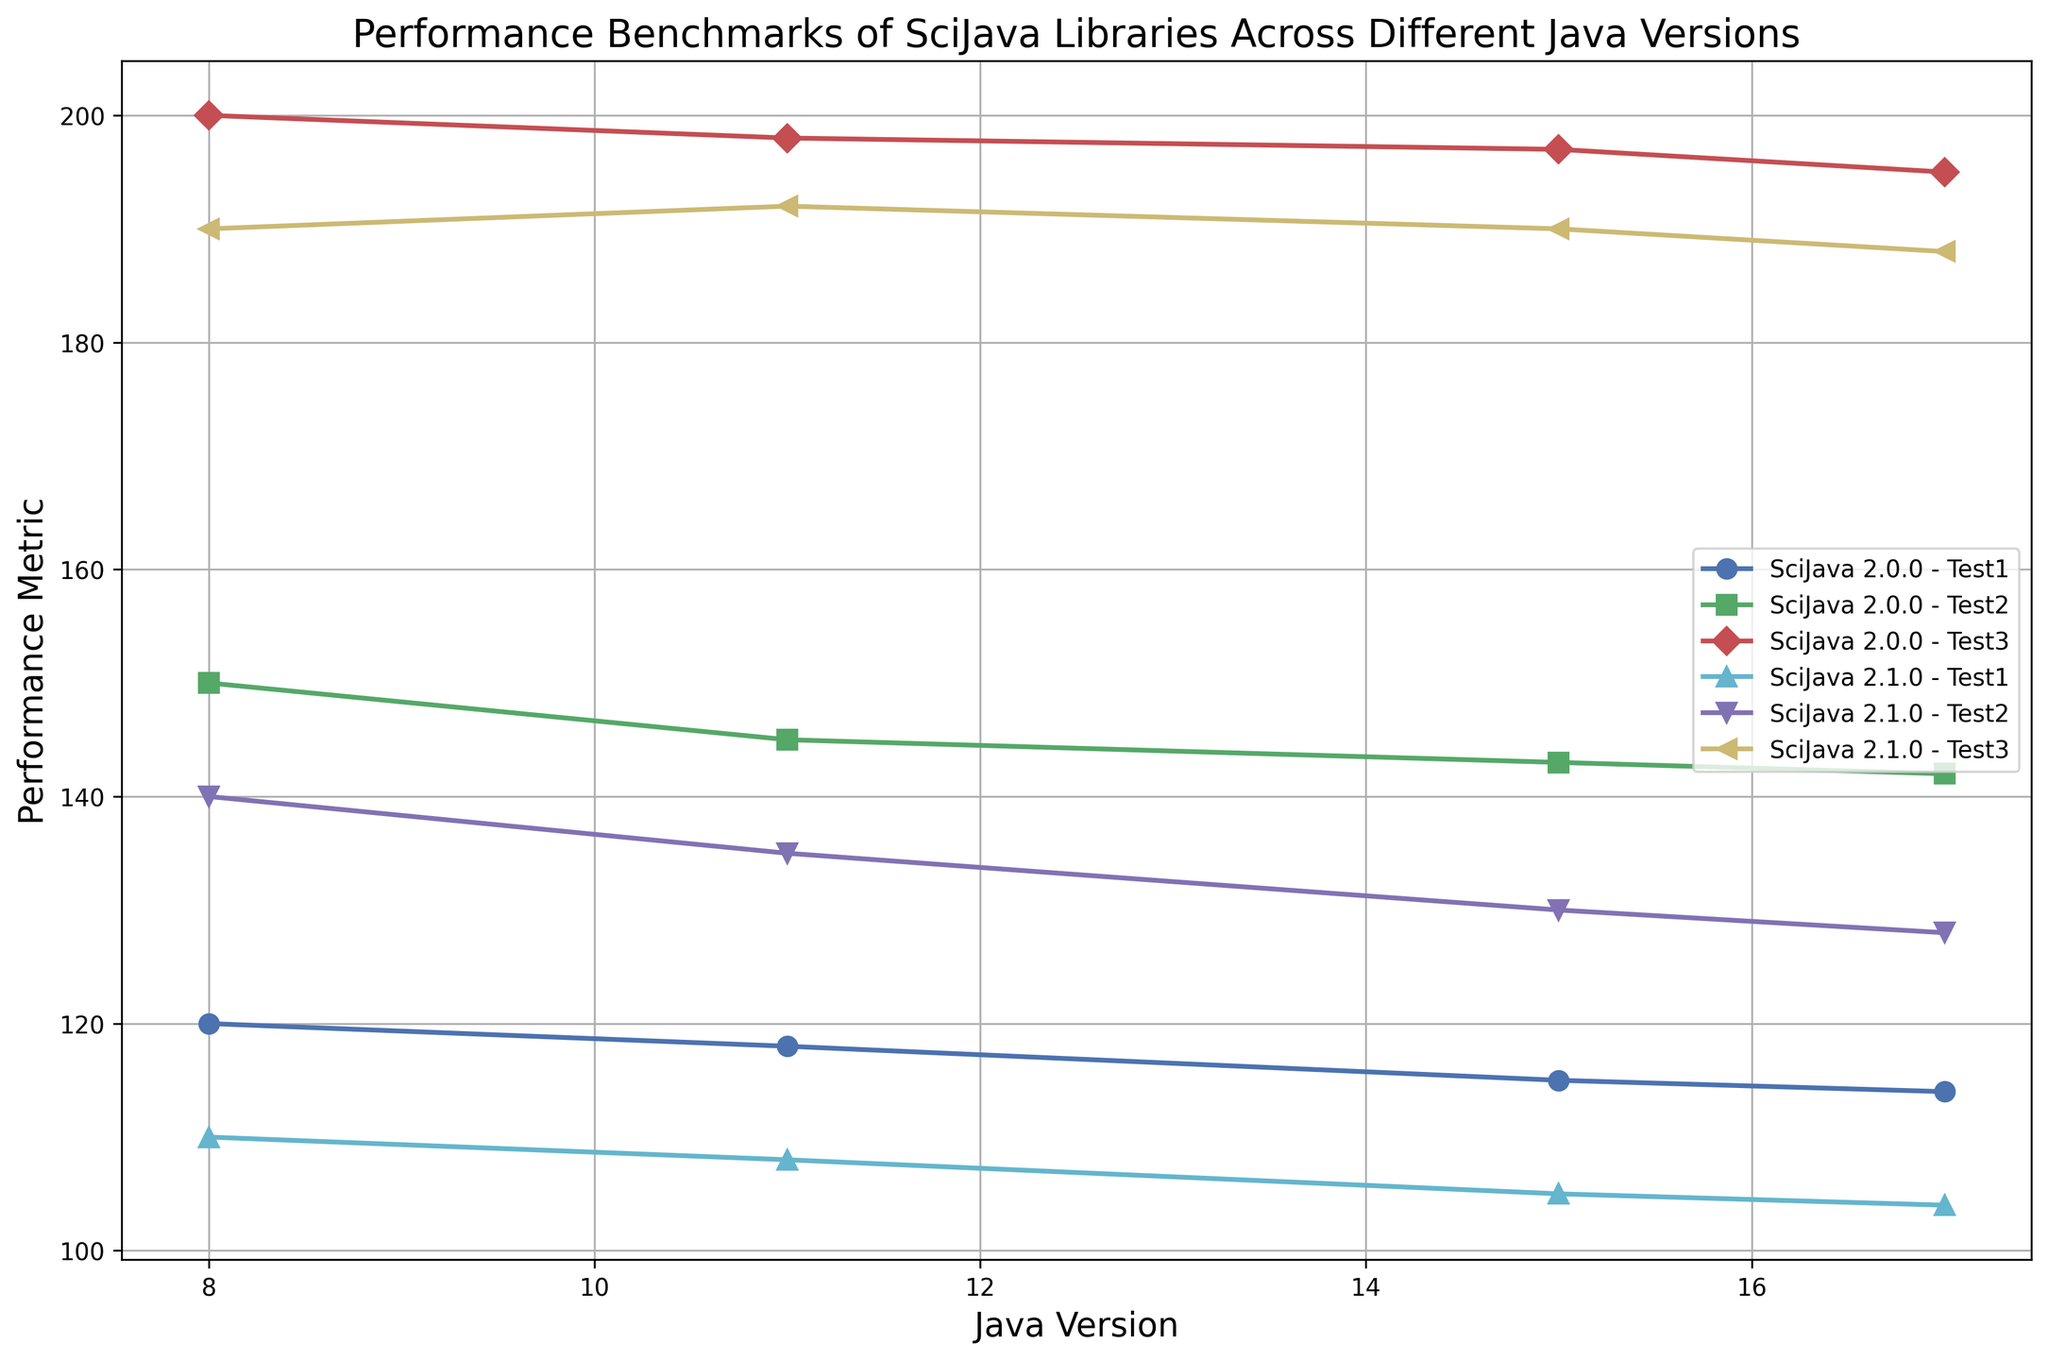Which Java version shows the best overall performance for SciJava 2.1.0? The performance metrics for SciJava 2.1.0 across different Java versions are: Java 8 (110, 140, 190), Java 11 (108, 135, 192), Java 15 (105, 130, 190), and Java 17 (104, 128, 188). Summing these up gives: Java 8 (440), Java 11 (435), Java 15 (425), Java 17 (420). The highest sum indicates the best performance, which is Java 8 with 440.
Answer: Java 8 How does the performance of SciJava 2.1.0 on Java 17 compare with SciJava 2.0.0 on Java 17 for Test 2? For Java 17, SciJava 2.1.0 has a performance metric of 128 for Test 2, while SciJava 2.0.0 has a performance metric of 142 for Test 2. Comparing these values shows that SciJava 2.1.0 performs worse than SciJava 2.0.0 for Test 2.
Answer: SciJava 2.0.0 performs better Which test shows the smallest difference in performance between SciJava 2.0.0 on Java 8 and SciJava 2.1.0 on Java 8? For Java 8, the performance metrics for Test 1 are 120 (SciJava 2.0.0) and 110 (SciJava 2.1.0); for Test 2, they are 150 (SciJava 2.0.0) and 140 (SciJava 2.1.0); for Test 3, they are 200 (SciJava 2.0.0) and 190 (SciJava 2.1.0). The differences are 10 for Test 1, 10 for Test 2, and 10 for Test 3. All differences are equal, so Tests 1, 2, and 3 all show the smallest difference in performance.
Answer: Tests 1, 2, and 3 equally What trend do you observe in the performance metrics of SciJava 2.1.0 tests from Java 8 to Java 17? The performance metrics for SciJava 2.1.0 show a decreasing trend across all tests as we move from Java 8 to Java 17. For Test 1, the metric declines from 110 down to 104. For Test 2, it declines from 140 down to 128. For Test 3, it declines from 190 down to 188. The trend is a general decrease in performance from Java 8 to Java 17.
Answer: Decreasing trend What is the average performance metric of SciJava 2.0.0 on Java 11? The performance metrics of SciJava 2.0.0 on Java 11 are 118 (Test 1), 145 (Test 2), and 198 (Test 3). To find the average: (118 + 145 + 198) / 3 = 153.67.
Answer: 153.67 Which test has the highest performance metric for SciJava 2.0.0 on Java 15? When looking at the performance metrics of SciJava 2.0.0 on Java 15, the values for Tests 1, 2, and 3 are 115, 143, and 197 respectively. Test 3 has the highest performance metric.
Answer: Test 3 Does the performance of SciJava 2.0.0 generally improve or decline with newer Java versions? Observing the performance metrics of SciJava 2.0.0 across Java versions 8, 11, 15, and 17, there's a slight decline for each corresponding test: Test 1 (120, 118, 115, 114), Test 2 (150, 145, 143, 142), Test 3 (200, 198, 197, 195). This indicates a general decline in performance with newer Java versions.
Answer: Generally decline What is the difference between the highest and lowest performance metrics for SciJava 2.1.0 on Java 8? For SciJava 2.1.0 on Java 8, the performance metrics are 110 (Test 1), 140 (Test 2), and 190 (Test 3). The highest is 190 and the lowest is 110. The difference is 190 - 110 = 80.
Answer: 80 